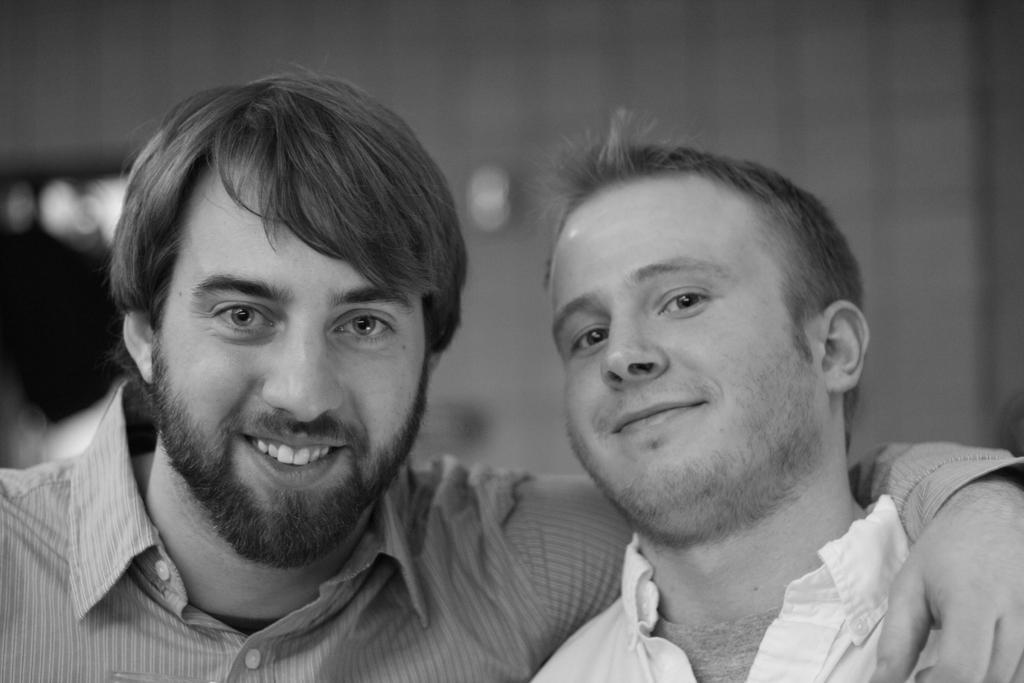Can you describe this image briefly? In this image we can see two people smiling. 